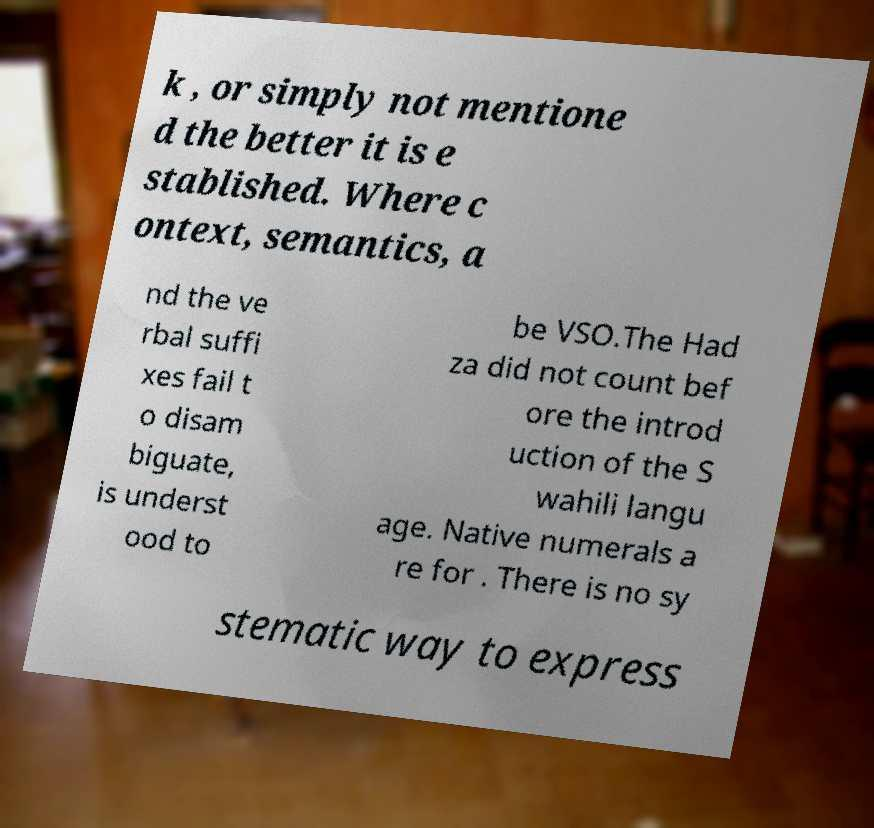Please identify and transcribe the text found in this image. k , or simply not mentione d the better it is e stablished. Where c ontext, semantics, a nd the ve rbal suffi xes fail t o disam biguate, is underst ood to be VSO.The Had za did not count bef ore the introd uction of the S wahili langu age. Native numerals a re for . There is no sy stematic way to express 